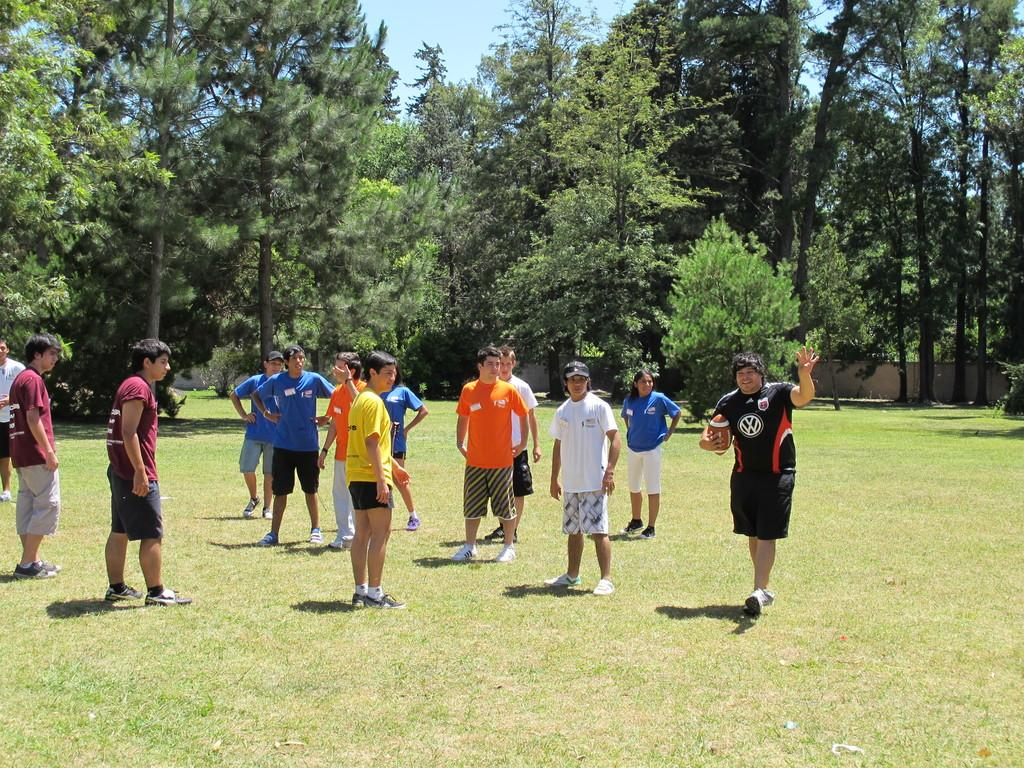Who or what can be seen in the image? There are people in the image. What type of natural environment is visible in the image? There is grass and trees in the image. What is visible at the top of the image? The sky is visible at the top of the image. What color crayon is being used to draw on the wire in the image? There is no wire or crayon present in the image. Where is the store located in the image? There is no store present in the image. 